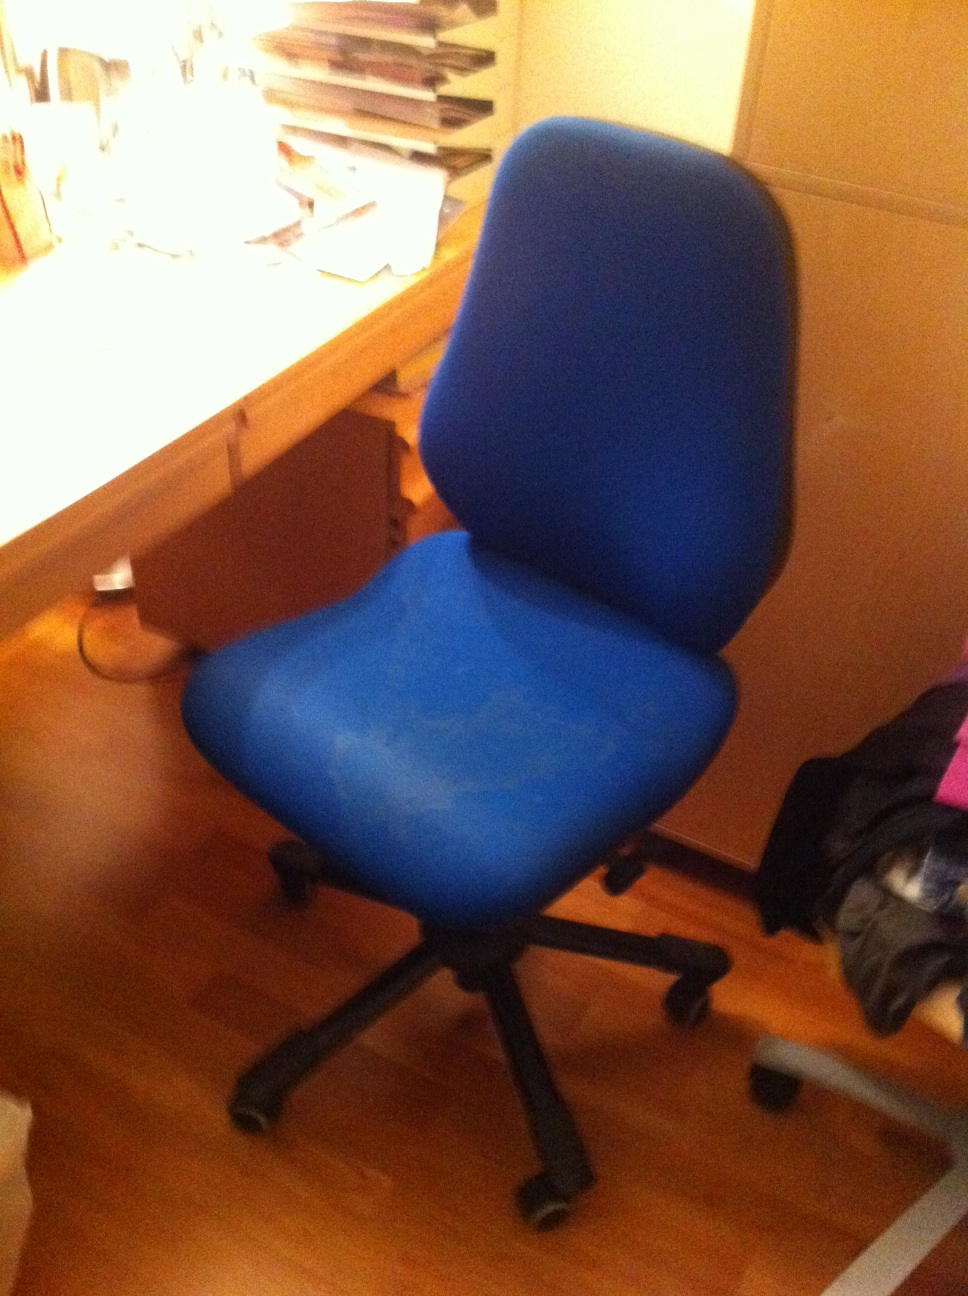Imagine this chair could talk. What would it tell us about its daily experiences? If this blue office chair could talk, it might say: 'Every day, I support someone working or studying diligently at this desk. I hear the rustling of papers and the tapping of keyboards as they focus on their tasks. Sometimes, they take a break and lean back, often reading or pondering deeply. It's a busy life for me, but I'm glad to be of service and to provide comfort through the long hours.' What challenges might this chair face during its lifetime? Throughout its lifetime, this chair might face several challenges. Regular wear and tear from daily use could lead to the fabric wearing thin or the cushioning becoming less supportive. The wheels could also become less smooth over time, making it harder to move around. Spills from drinks or food could cause stains or damage to the material. Additionally, if the chair is not used properly, such as being leaned back on too often or used for purposes beyond sitting, it could risk structural damage. 